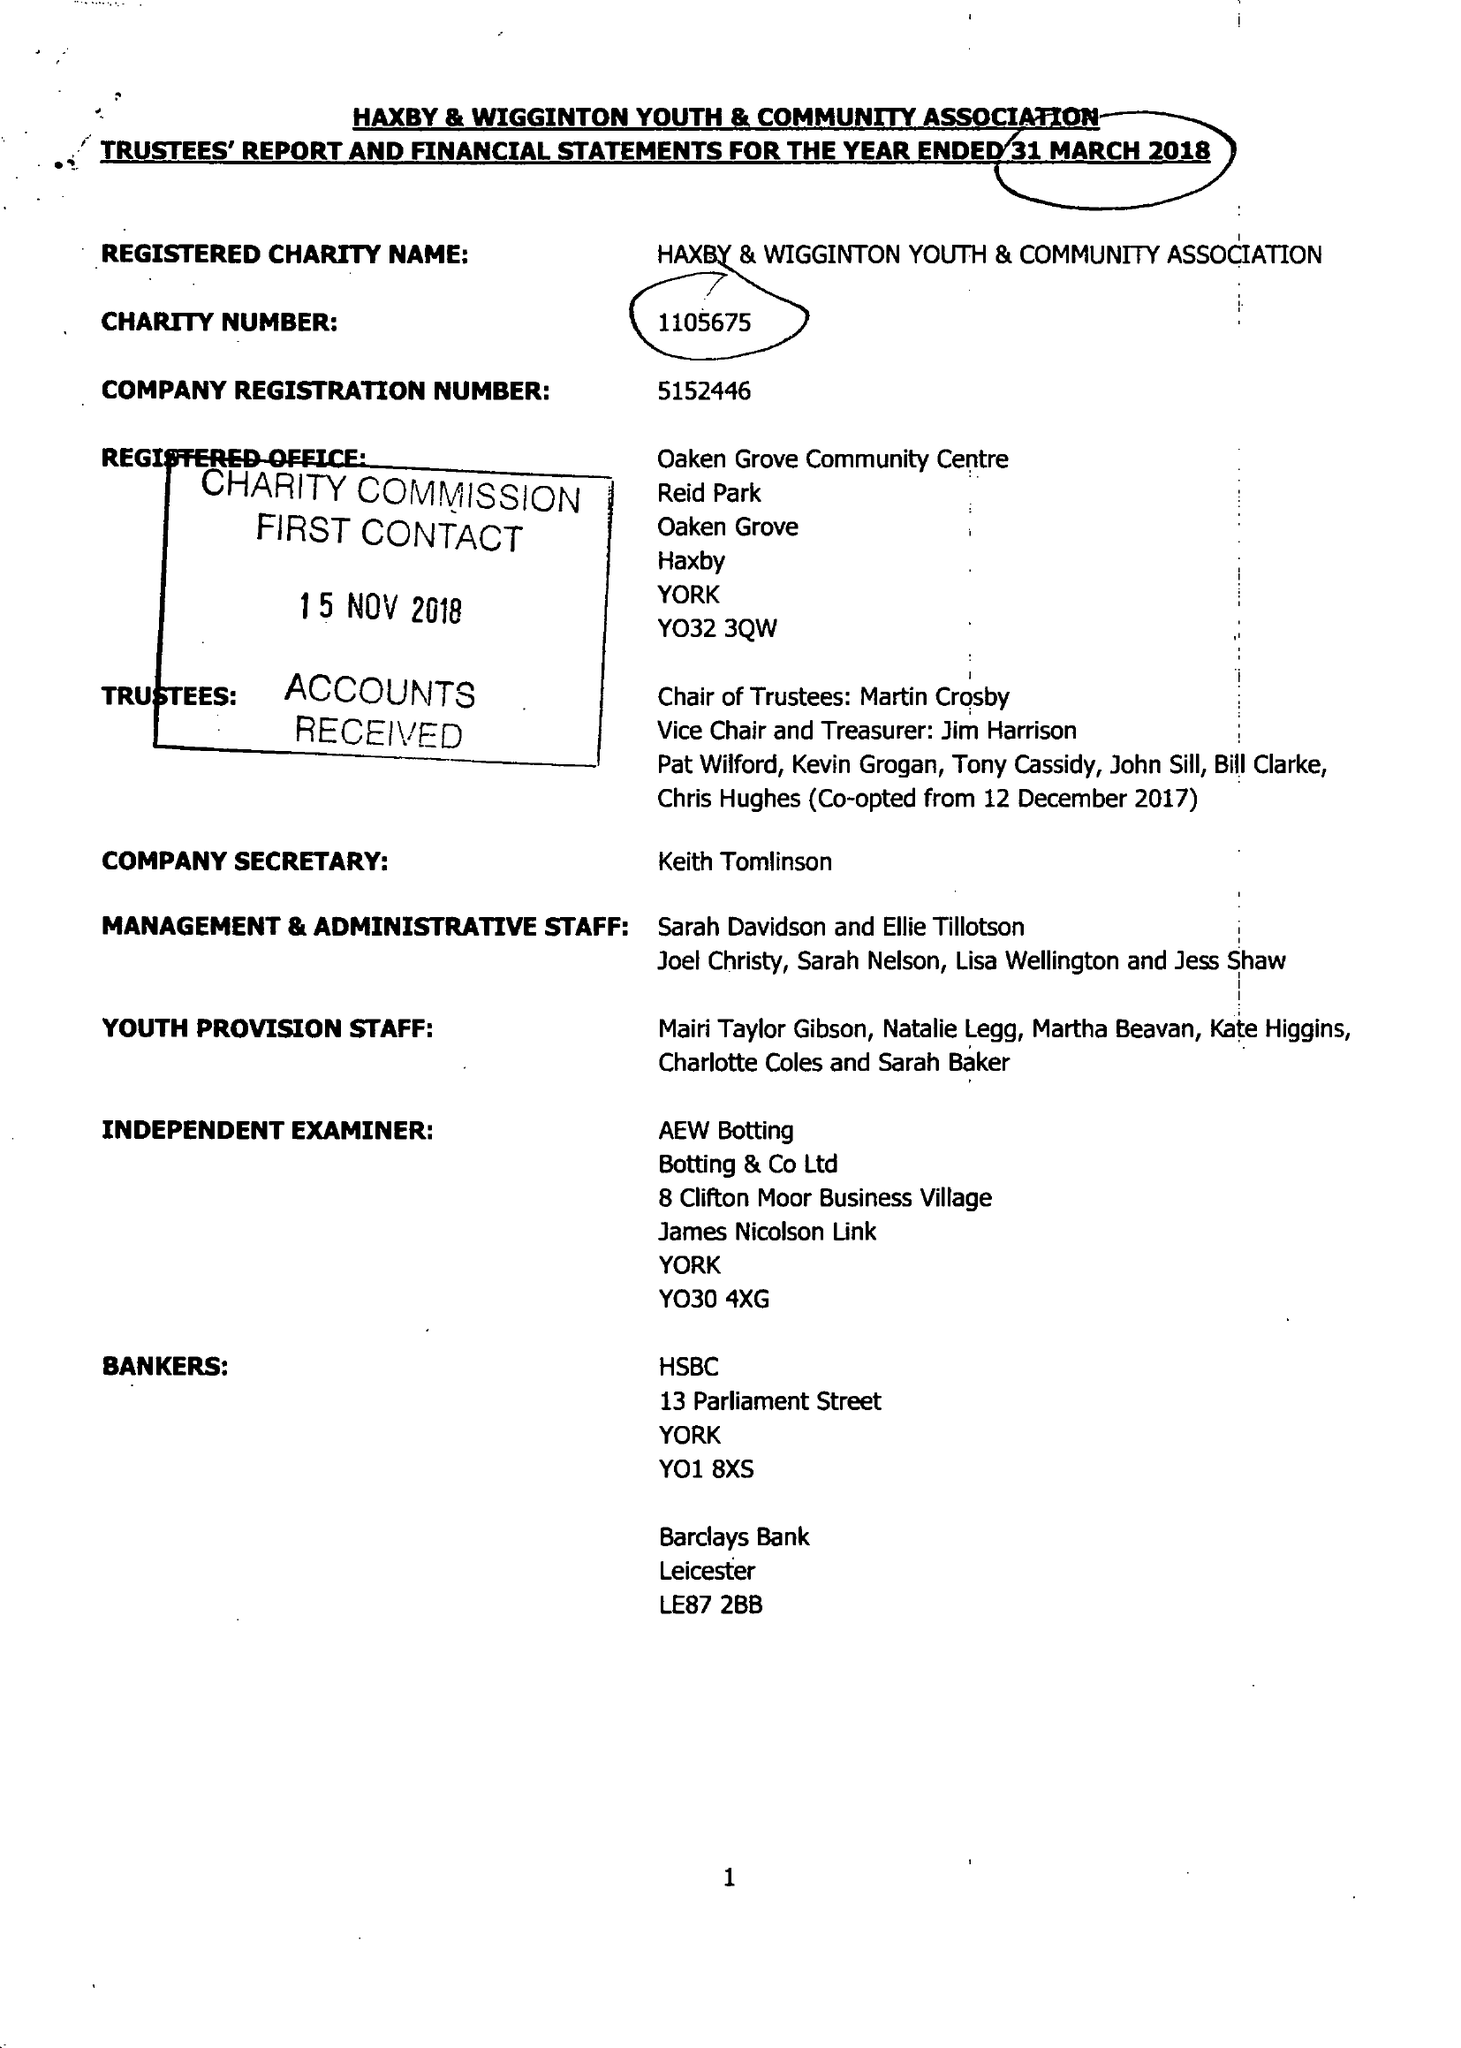What is the value for the spending_annually_in_british_pounds?
Answer the question using a single word or phrase. 84857.00 